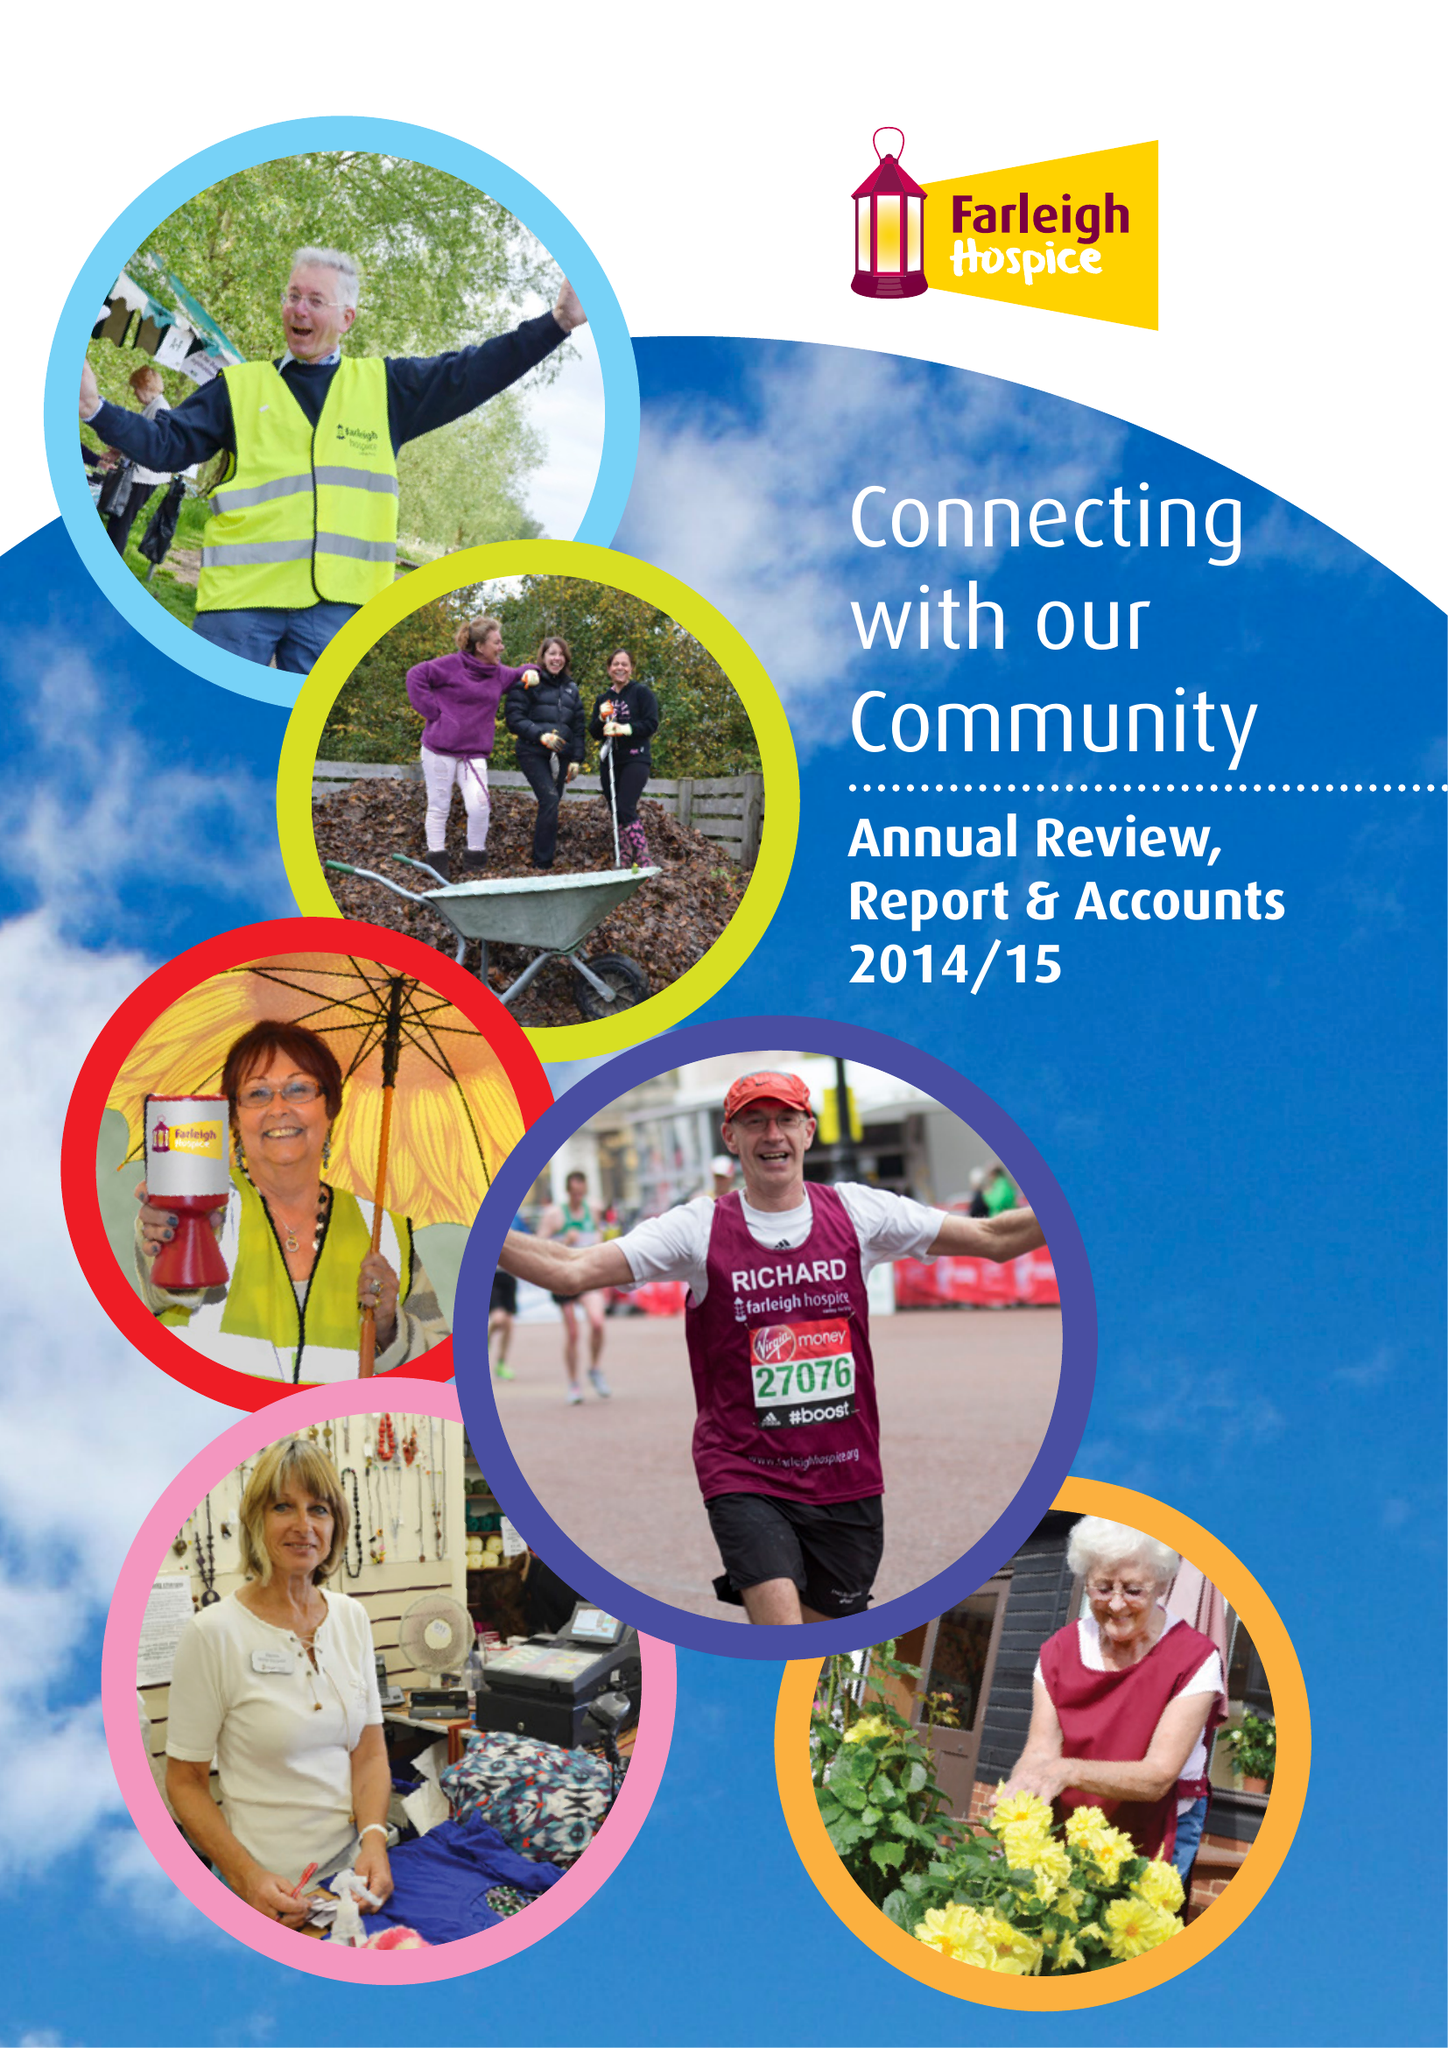What is the value for the spending_annually_in_british_pounds?
Answer the question using a single word or phrase. 8951630.00 